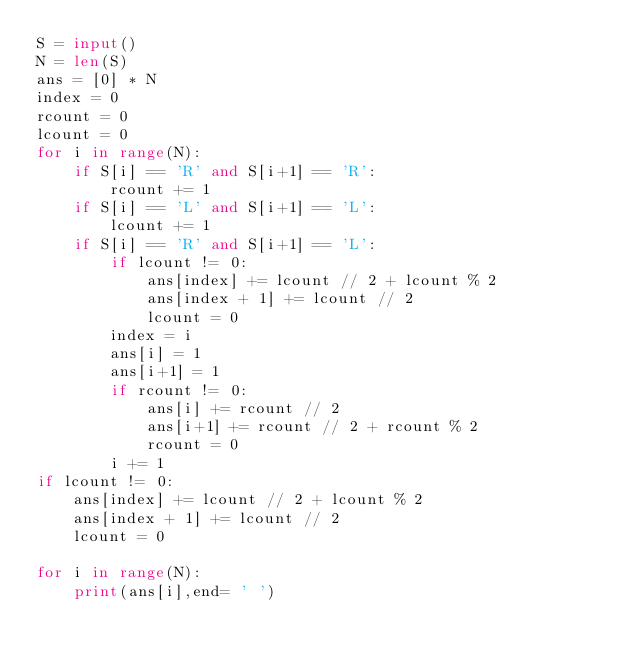Convert code to text. <code><loc_0><loc_0><loc_500><loc_500><_Python_>S = input()
N = len(S)
ans = [0] * N
index = 0
rcount = 0
lcount = 0
for i in range(N):
    if S[i] == 'R' and S[i+1] == 'R':
        rcount += 1
    if S[i] == 'L' and S[i+1] == 'L':
        lcount += 1
    if S[i] == 'R' and S[i+1] == 'L':
        if lcount != 0:
            ans[index] += lcount // 2 + lcount % 2
            ans[index + 1] += lcount // 2
            lcount = 0
        index = i
        ans[i] = 1
        ans[i+1] = 1
        if rcount != 0:
            ans[i] += rcount // 2
            ans[i+1] += rcount // 2 + rcount % 2
            rcount = 0
        i += 1
if lcount != 0:
    ans[index] += lcount // 2 + lcount % 2
    ans[index + 1] += lcount // 2
    lcount = 0

for i in range(N):
    print(ans[i],end= ' ')</code> 